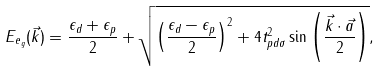Convert formula to latex. <formula><loc_0><loc_0><loc_500><loc_500>E _ { e _ { g } } ( \vec { k } ) = \frac { \epsilon _ { d } + \epsilon _ { p } } { 2 } + \sqrt { \left ( \frac { \epsilon _ { d } - \epsilon _ { p } } { 2 } \right ) ^ { 2 } + 4 t _ { p d \sigma } ^ { 2 } \sin \left ( \frac { \vec { k } \cdot \vec { a } } { 2 } \right ) } ,</formula> 